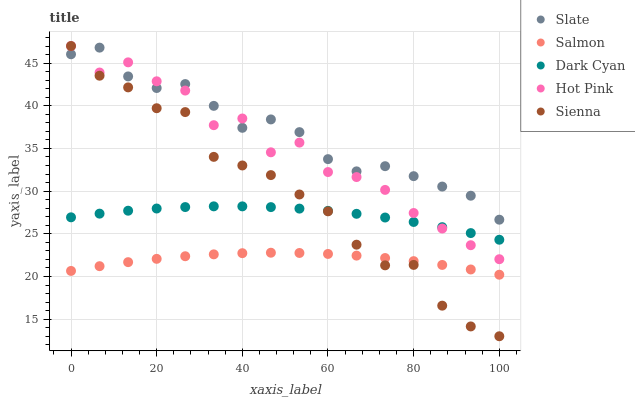Does Salmon have the minimum area under the curve?
Answer yes or no. Yes. Does Slate have the maximum area under the curve?
Answer yes or no. Yes. Does Sienna have the minimum area under the curve?
Answer yes or no. No. Does Sienna have the maximum area under the curve?
Answer yes or no. No. Is Salmon the smoothest?
Answer yes or no. Yes. Is Hot Pink the roughest?
Answer yes or no. Yes. Is Sienna the smoothest?
Answer yes or no. No. Is Sienna the roughest?
Answer yes or no. No. Does Sienna have the lowest value?
Answer yes or no. Yes. Does Slate have the lowest value?
Answer yes or no. No. Does Hot Pink have the highest value?
Answer yes or no. Yes. Does Slate have the highest value?
Answer yes or no. No. Is Dark Cyan less than Slate?
Answer yes or no. Yes. Is Slate greater than Dark Cyan?
Answer yes or no. Yes. Does Sienna intersect Slate?
Answer yes or no. Yes. Is Sienna less than Slate?
Answer yes or no. No. Is Sienna greater than Slate?
Answer yes or no. No. Does Dark Cyan intersect Slate?
Answer yes or no. No. 